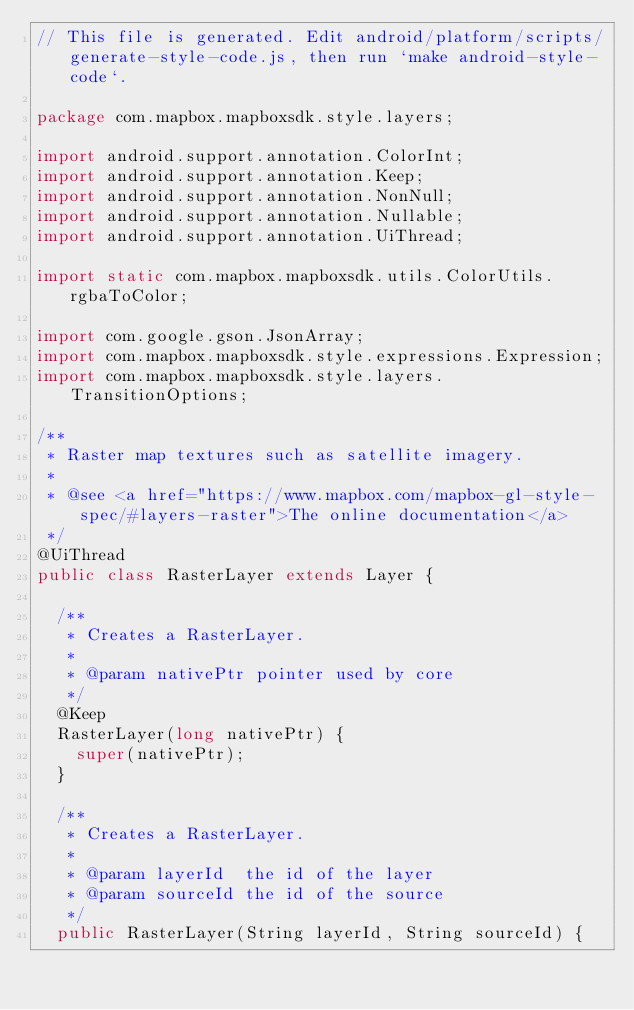<code> <loc_0><loc_0><loc_500><loc_500><_Java_>// This file is generated. Edit android/platform/scripts/generate-style-code.js, then run `make android-style-code`.

package com.mapbox.mapboxsdk.style.layers;

import android.support.annotation.ColorInt;
import android.support.annotation.Keep;
import android.support.annotation.NonNull;
import android.support.annotation.Nullable;
import android.support.annotation.UiThread;

import static com.mapbox.mapboxsdk.utils.ColorUtils.rgbaToColor;

import com.google.gson.JsonArray;
import com.mapbox.mapboxsdk.style.expressions.Expression;
import com.mapbox.mapboxsdk.style.layers.TransitionOptions;

/**
 * Raster map textures such as satellite imagery.
 *
 * @see <a href="https://www.mapbox.com/mapbox-gl-style-spec/#layers-raster">The online documentation</a>
 */
@UiThread
public class RasterLayer extends Layer {

  /**
   * Creates a RasterLayer.
   *
   * @param nativePtr pointer used by core
   */
  @Keep
  RasterLayer(long nativePtr) {
    super(nativePtr);
  }

  /**
   * Creates a RasterLayer.
   *
   * @param layerId  the id of the layer
   * @param sourceId the id of the source
   */
  public RasterLayer(String layerId, String sourceId) {</code> 